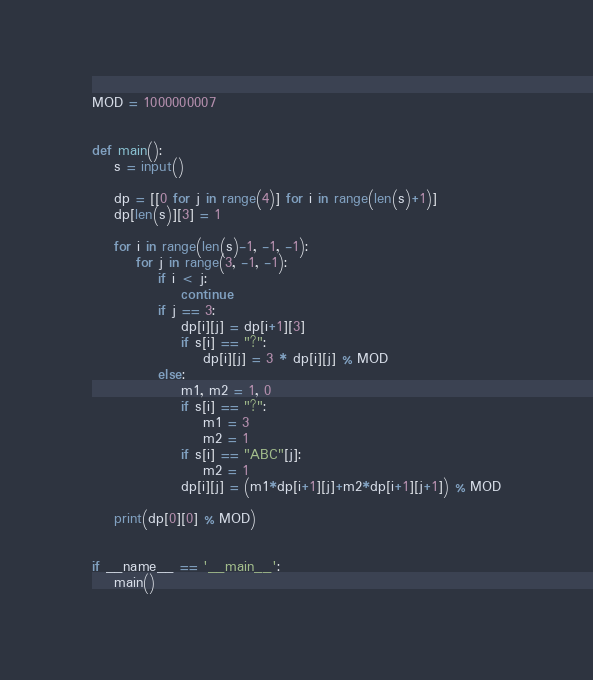Convert code to text. <code><loc_0><loc_0><loc_500><loc_500><_Python_>MOD = 1000000007


def main():
    s = input()

    dp = [[0 for j in range(4)] for i in range(len(s)+1)]
    dp[len(s)][3] = 1

    for i in range(len(s)-1, -1, -1):
        for j in range(3, -1, -1):
            if i < j:
                continue
            if j == 3:
                dp[i][j] = dp[i+1][3]
                if s[i] == "?":
                    dp[i][j] = 3 * dp[i][j] % MOD
            else:
                m1, m2 = 1, 0
                if s[i] == "?":
                    m1 = 3
                    m2 = 1
                if s[i] == "ABC"[j]:
                    m2 = 1
                dp[i][j] = (m1*dp[i+1][j]+m2*dp[i+1][j+1]) % MOD

    print(dp[0][0] % MOD)


if __name__ == '__main__':
    main()
</code> 